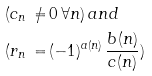<formula> <loc_0><loc_0><loc_500><loc_500>( c _ { n } \, \neq & \, 0 \, \forall n ) \, a n d \\ ( r _ { n } \, = & \, ( - 1 ) ^ { a ( n ) } \, \frac { b ( n ) } { c ( n ) } )</formula> 